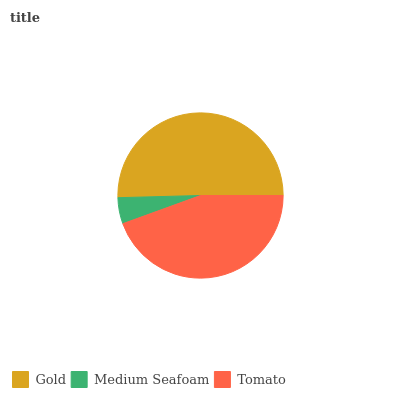Is Medium Seafoam the minimum?
Answer yes or no. Yes. Is Gold the maximum?
Answer yes or no. Yes. Is Tomato the minimum?
Answer yes or no. No. Is Tomato the maximum?
Answer yes or no. No. Is Tomato greater than Medium Seafoam?
Answer yes or no. Yes. Is Medium Seafoam less than Tomato?
Answer yes or no. Yes. Is Medium Seafoam greater than Tomato?
Answer yes or no. No. Is Tomato less than Medium Seafoam?
Answer yes or no. No. Is Tomato the high median?
Answer yes or no. Yes. Is Tomato the low median?
Answer yes or no. Yes. Is Gold the high median?
Answer yes or no. No. Is Gold the low median?
Answer yes or no. No. 